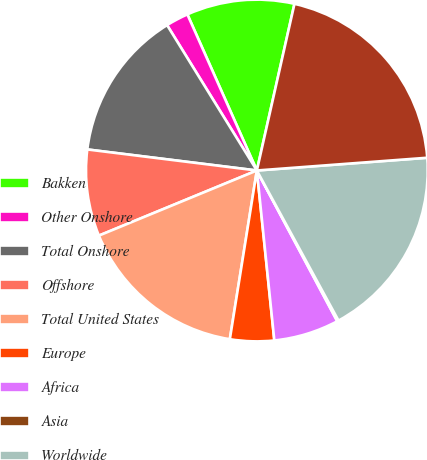Convert chart to OTSL. <chart><loc_0><loc_0><loc_500><loc_500><pie_chart><fcel>Bakken<fcel>Other Onshore<fcel>Total Onshore<fcel>Offshore<fcel>Total United States<fcel>Europe<fcel>Africa<fcel>Asia<fcel>Worldwide<fcel>Barrels of Oil Equivalent<nl><fcel>10.2%<fcel>2.14%<fcel>14.23%<fcel>8.19%<fcel>16.25%<fcel>4.16%<fcel>6.17%<fcel>0.13%<fcel>18.26%<fcel>20.28%<nl></chart> 